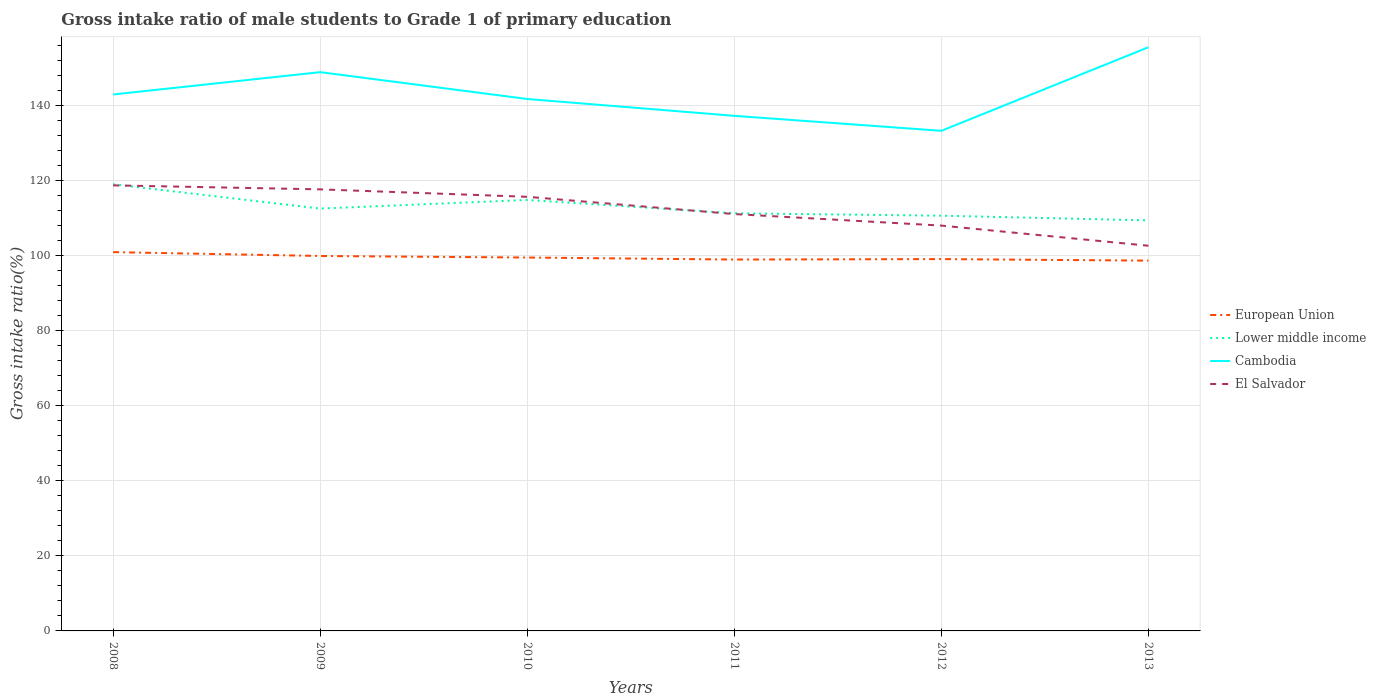How many different coloured lines are there?
Offer a very short reply. 4. Does the line corresponding to European Union intersect with the line corresponding to Lower middle income?
Your answer should be very brief. No. Across all years, what is the maximum gross intake ratio in Lower middle income?
Provide a short and direct response. 109.4. In which year was the gross intake ratio in Cambodia maximum?
Your answer should be very brief. 2012. What is the total gross intake ratio in El Salvador in the graph?
Your answer should be very brief. 1.98. What is the difference between the highest and the second highest gross intake ratio in European Union?
Your answer should be very brief. 2.26. What is the difference between the highest and the lowest gross intake ratio in European Union?
Your response must be concise. 2. Is the gross intake ratio in European Union strictly greater than the gross intake ratio in El Salvador over the years?
Provide a short and direct response. Yes. Are the values on the major ticks of Y-axis written in scientific E-notation?
Your response must be concise. No. Does the graph contain any zero values?
Your response must be concise. No. How many legend labels are there?
Provide a succinct answer. 4. How are the legend labels stacked?
Offer a terse response. Vertical. What is the title of the graph?
Offer a terse response. Gross intake ratio of male students to Grade 1 of primary education. What is the label or title of the X-axis?
Your answer should be very brief. Years. What is the label or title of the Y-axis?
Give a very brief answer. Gross intake ratio(%). What is the Gross intake ratio(%) of European Union in 2008?
Provide a short and direct response. 100.94. What is the Gross intake ratio(%) of Lower middle income in 2008?
Provide a succinct answer. 119.01. What is the Gross intake ratio(%) in Cambodia in 2008?
Offer a terse response. 142.95. What is the Gross intake ratio(%) in El Salvador in 2008?
Your response must be concise. 118.73. What is the Gross intake ratio(%) in European Union in 2009?
Make the answer very short. 99.91. What is the Gross intake ratio(%) in Lower middle income in 2009?
Provide a short and direct response. 112.54. What is the Gross intake ratio(%) of Cambodia in 2009?
Provide a short and direct response. 148.9. What is the Gross intake ratio(%) of El Salvador in 2009?
Make the answer very short. 117.67. What is the Gross intake ratio(%) of European Union in 2010?
Your answer should be very brief. 99.5. What is the Gross intake ratio(%) of Lower middle income in 2010?
Provide a short and direct response. 114.85. What is the Gross intake ratio(%) of Cambodia in 2010?
Ensure brevity in your answer.  141.75. What is the Gross intake ratio(%) in El Salvador in 2010?
Your response must be concise. 115.68. What is the Gross intake ratio(%) of European Union in 2011?
Offer a terse response. 98.96. What is the Gross intake ratio(%) of Lower middle income in 2011?
Make the answer very short. 111.29. What is the Gross intake ratio(%) of Cambodia in 2011?
Keep it short and to the point. 137.26. What is the Gross intake ratio(%) of El Salvador in 2011?
Your response must be concise. 111.08. What is the Gross intake ratio(%) of European Union in 2012?
Provide a short and direct response. 99.08. What is the Gross intake ratio(%) of Lower middle income in 2012?
Offer a very short reply. 110.65. What is the Gross intake ratio(%) in Cambodia in 2012?
Provide a short and direct response. 133.27. What is the Gross intake ratio(%) in El Salvador in 2012?
Give a very brief answer. 108.01. What is the Gross intake ratio(%) of European Union in 2013?
Offer a very short reply. 98.68. What is the Gross intake ratio(%) in Lower middle income in 2013?
Ensure brevity in your answer.  109.4. What is the Gross intake ratio(%) of Cambodia in 2013?
Provide a short and direct response. 155.54. What is the Gross intake ratio(%) in El Salvador in 2013?
Offer a terse response. 102.64. Across all years, what is the maximum Gross intake ratio(%) of European Union?
Offer a terse response. 100.94. Across all years, what is the maximum Gross intake ratio(%) in Lower middle income?
Your answer should be very brief. 119.01. Across all years, what is the maximum Gross intake ratio(%) in Cambodia?
Your response must be concise. 155.54. Across all years, what is the maximum Gross intake ratio(%) in El Salvador?
Keep it short and to the point. 118.73. Across all years, what is the minimum Gross intake ratio(%) of European Union?
Your response must be concise. 98.68. Across all years, what is the minimum Gross intake ratio(%) of Lower middle income?
Your answer should be very brief. 109.4. Across all years, what is the minimum Gross intake ratio(%) of Cambodia?
Keep it short and to the point. 133.27. Across all years, what is the minimum Gross intake ratio(%) in El Salvador?
Your response must be concise. 102.64. What is the total Gross intake ratio(%) in European Union in the graph?
Your response must be concise. 597.07. What is the total Gross intake ratio(%) in Lower middle income in the graph?
Ensure brevity in your answer.  677.73. What is the total Gross intake ratio(%) in Cambodia in the graph?
Ensure brevity in your answer.  859.65. What is the total Gross intake ratio(%) in El Salvador in the graph?
Give a very brief answer. 673.82. What is the difference between the Gross intake ratio(%) in European Union in 2008 and that in 2009?
Give a very brief answer. 1.03. What is the difference between the Gross intake ratio(%) of Lower middle income in 2008 and that in 2009?
Offer a terse response. 6.47. What is the difference between the Gross intake ratio(%) of Cambodia in 2008 and that in 2009?
Give a very brief answer. -5.95. What is the difference between the Gross intake ratio(%) in El Salvador in 2008 and that in 2009?
Your answer should be very brief. 1.06. What is the difference between the Gross intake ratio(%) of European Union in 2008 and that in 2010?
Provide a succinct answer. 1.44. What is the difference between the Gross intake ratio(%) in Lower middle income in 2008 and that in 2010?
Offer a very short reply. 4.17. What is the difference between the Gross intake ratio(%) of Cambodia in 2008 and that in 2010?
Ensure brevity in your answer.  1.2. What is the difference between the Gross intake ratio(%) of El Salvador in 2008 and that in 2010?
Provide a succinct answer. 3.05. What is the difference between the Gross intake ratio(%) in European Union in 2008 and that in 2011?
Ensure brevity in your answer.  1.98. What is the difference between the Gross intake ratio(%) of Lower middle income in 2008 and that in 2011?
Provide a short and direct response. 7.72. What is the difference between the Gross intake ratio(%) in Cambodia in 2008 and that in 2011?
Make the answer very short. 5.69. What is the difference between the Gross intake ratio(%) of El Salvador in 2008 and that in 2011?
Give a very brief answer. 7.65. What is the difference between the Gross intake ratio(%) of European Union in 2008 and that in 2012?
Provide a succinct answer. 1.86. What is the difference between the Gross intake ratio(%) of Lower middle income in 2008 and that in 2012?
Your response must be concise. 8.36. What is the difference between the Gross intake ratio(%) in Cambodia in 2008 and that in 2012?
Provide a succinct answer. 9.68. What is the difference between the Gross intake ratio(%) in El Salvador in 2008 and that in 2012?
Your answer should be compact. 10.72. What is the difference between the Gross intake ratio(%) in European Union in 2008 and that in 2013?
Your answer should be very brief. 2.26. What is the difference between the Gross intake ratio(%) in Lower middle income in 2008 and that in 2013?
Offer a terse response. 9.62. What is the difference between the Gross intake ratio(%) of Cambodia in 2008 and that in 2013?
Offer a very short reply. -12.59. What is the difference between the Gross intake ratio(%) of El Salvador in 2008 and that in 2013?
Make the answer very short. 16.09. What is the difference between the Gross intake ratio(%) of European Union in 2009 and that in 2010?
Your response must be concise. 0.41. What is the difference between the Gross intake ratio(%) in Lower middle income in 2009 and that in 2010?
Make the answer very short. -2.3. What is the difference between the Gross intake ratio(%) of Cambodia in 2009 and that in 2010?
Keep it short and to the point. 7.15. What is the difference between the Gross intake ratio(%) in El Salvador in 2009 and that in 2010?
Offer a very short reply. 1.98. What is the difference between the Gross intake ratio(%) in European Union in 2009 and that in 2011?
Ensure brevity in your answer.  0.95. What is the difference between the Gross intake ratio(%) of Lower middle income in 2009 and that in 2011?
Keep it short and to the point. 1.26. What is the difference between the Gross intake ratio(%) in Cambodia in 2009 and that in 2011?
Your answer should be compact. 11.64. What is the difference between the Gross intake ratio(%) of El Salvador in 2009 and that in 2011?
Provide a succinct answer. 6.58. What is the difference between the Gross intake ratio(%) of European Union in 2009 and that in 2012?
Your answer should be compact. 0.83. What is the difference between the Gross intake ratio(%) of Lower middle income in 2009 and that in 2012?
Make the answer very short. 1.89. What is the difference between the Gross intake ratio(%) of Cambodia in 2009 and that in 2012?
Provide a short and direct response. 15.63. What is the difference between the Gross intake ratio(%) in El Salvador in 2009 and that in 2012?
Provide a succinct answer. 9.65. What is the difference between the Gross intake ratio(%) of European Union in 2009 and that in 2013?
Give a very brief answer. 1.24. What is the difference between the Gross intake ratio(%) in Lower middle income in 2009 and that in 2013?
Your answer should be compact. 3.15. What is the difference between the Gross intake ratio(%) of Cambodia in 2009 and that in 2013?
Offer a terse response. -6.64. What is the difference between the Gross intake ratio(%) in El Salvador in 2009 and that in 2013?
Ensure brevity in your answer.  15.02. What is the difference between the Gross intake ratio(%) of European Union in 2010 and that in 2011?
Provide a succinct answer. 0.54. What is the difference between the Gross intake ratio(%) in Lower middle income in 2010 and that in 2011?
Keep it short and to the point. 3.56. What is the difference between the Gross intake ratio(%) in Cambodia in 2010 and that in 2011?
Ensure brevity in your answer.  4.49. What is the difference between the Gross intake ratio(%) in El Salvador in 2010 and that in 2011?
Offer a very short reply. 4.6. What is the difference between the Gross intake ratio(%) in European Union in 2010 and that in 2012?
Offer a very short reply. 0.42. What is the difference between the Gross intake ratio(%) of Lower middle income in 2010 and that in 2012?
Your response must be concise. 4.19. What is the difference between the Gross intake ratio(%) of Cambodia in 2010 and that in 2012?
Offer a very short reply. 8.48. What is the difference between the Gross intake ratio(%) in El Salvador in 2010 and that in 2012?
Your response must be concise. 7.67. What is the difference between the Gross intake ratio(%) in European Union in 2010 and that in 2013?
Your answer should be very brief. 0.83. What is the difference between the Gross intake ratio(%) in Lower middle income in 2010 and that in 2013?
Keep it short and to the point. 5.45. What is the difference between the Gross intake ratio(%) of Cambodia in 2010 and that in 2013?
Ensure brevity in your answer.  -13.79. What is the difference between the Gross intake ratio(%) of El Salvador in 2010 and that in 2013?
Keep it short and to the point. 13.04. What is the difference between the Gross intake ratio(%) of European Union in 2011 and that in 2012?
Offer a terse response. -0.12. What is the difference between the Gross intake ratio(%) of Lower middle income in 2011 and that in 2012?
Ensure brevity in your answer.  0.64. What is the difference between the Gross intake ratio(%) of Cambodia in 2011 and that in 2012?
Your answer should be very brief. 3.99. What is the difference between the Gross intake ratio(%) of El Salvador in 2011 and that in 2012?
Offer a very short reply. 3.07. What is the difference between the Gross intake ratio(%) in European Union in 2011 and that in 2013?
Provide a succinct answer. 0.28. What is the difference between the Gross intake ratio(%) in Lower middle income in 2011 and that in 2013?
Provide a succinct answer. 1.89. What is the difference between the Gross intake ratio(%) in Cambodia in 2011 and that in 2013?
Provide a short and direct response. -18.28. What is the difference between the Gross intake ratio(%) in El Salvador in 2011 and that in 2013?
Provide a succinct answer. 8.44. What is the difference between the Gross intake ratio(%) in European Union in 2012 and that in 2013?
Offer a terse response. 0.41. What is the difference between the Gross intake ratio(%) of Lower middle income in 2012 and that in 2013?
Your answer should be compact. 1.26. What is the difference between the Gross intake ratio(%) in Cambodia in 2012 and that in 2013?
Your answer should be very brief. -22.27. What is the difference between the Gross intake ratio(%) of El Salvador in 2012 and that in 2013?
Offer a very short reply. 5.37. What is the difference between the Gross intake ratio(%) in European Union in 2008 and the Gross intake ratio(%) in Lower middle income in 2009?
Give a very brief answer. -11.6. What is the difference between the Gross intake ratio(%) of European Union in 2008 and the Gross intake ratio(%) of Cambodia in 2009?
Provide a short and direct response. -47.96. What is the difference between the Gross intake ratio(%) of European Union in 2008 and the Gross intake ratio(%) of El Salvador in 2009?
Offer a terse response. -16.73. What is the difference between the Gross intake ratio(%) in Lower middle income in 2008 and the Gross intake ratio(%) in Cambodia in 2009?
Your response must be concise. -29.89. What is the difference between the Gross intake ratio(%) of Lower middle income in 2008 and the Gross intake ratio(%) of El Salvador in 2009?
Provide a short and direct response. 1.35. What is the difference between the Gross intake ratio(%) of Cambodia in 2008 and the Gross intake ratio(%) of El Salvador in 2009?
Your response must be concise. 25.28. What is the difference between the Gross intake ratio(%) in European Union in 2008 and the Gross intake ratio(%) in Lower middle income in 2010?
Offer a terse response. -13.91. What is the difference between the Gross intake ratio(%) of European Union in 2008 and the Gross intake ratio(%) of Cambodia in 2010?
Your response must be concise. -40.81. What is the difference between the Gross intake ratio(%) of European Union in 2008 and the Gross intake ratio(%) of El Salvador in 2010?
Your answer should be very brief. -14.74. What is the difference between the Gross intake ratio(%) in Lower middle income in 2008 and the Gross intake ratio(%) in Cambodia in 2010?
Give a very brief answer. -22.73. What is the difference between the Gross intake ratio(%) of Lower middle income in 2008 and the Gross intake ratio(%) of El Salvador in 2010?
Offer a terse response. 3.33. What is the difference between the Gross intake ratio(%) in Cambodia in 2008 and the Gross intake ratio(%) in El Salvador in 2010?
Your answer should be compact. 27.27. What is the difference between the Gross intake ratio(%) of European Union in 2008 and the Gross intake ratio(%) of Lower middle income in 2011?
Provide a short and direct response. -10.35. What is the difference between the Gross intake ratio(%) in European Union in 2008 and the Gross intake ratio(%) in Cambodia in 2011?
Ensure brevity in your answer.  -36.32. What is the difference between the Gross intake ratio(%) in European Union in 2008 and the Gross intake ratio(%) in El Salvador in 2011?
Offer a very short reply. -10.14. What is the difference between the Gross intake ratio(%) in Lower middle income in 2008 and the Gross intake ratio(%) in Cambodia in 2011?
Offer a very short reply. -18.25. What is the difference between the Gross intake ratio(%) in Lower middle income in 2008 and the Gross intake ratio(%) in El Salvador in 2011?
Keep it short and to the point. 7.93. What is the difference between the Gross intake ratio(%) of Cambodia in 2008 and the Gross intake ratio(%) of El Salvador in 2011?
Provide a succinct answer. 31.87. What is the difference between the Gross intake ratio(%) of European Union in 2008 and the Gross intake ratio(%) of Lower middle income in 2012?
Offer a very short reply. -9.71. What is the difference between the Gross intake ratio(%) in European Union in 2008 and the Gross intake ratio(%) in Cambodia in 2012?
Make the answer very short. -32.33. What is the difference between the Gross intake ratio(%) in European Union in 2008 and the Gross intake ratio(%) in El Salvador in 2012?
Your response must be concise. -7.07. What is the difference between the Gross intake ratio(%) in Lower middle income in 2008 and the Gross intake ratio(%) in Cambodia in 2012?
Provide a succinct answer. -14.25. What is the difference between the Gross intake ratio(%) of Lower middle income in 2008 and the Gross intake ratio(%) of El Salvador in 2012?
Ensure brevity in your answer.  11. What is the difference between the Gross intake ratio(%) of Cambodia in 2008 and the Gross intake ratio(%) of El Salvador in 2012?
Your response must be concise. 34.94. What is the difference between the Gross intake ratio(%) in European Union in 2008 and the Gross intake ratio(%) in Lower middle income in 2013?
Keep it short and to the point. -8.46. What is the difference between the Gross intake ratio(%) of European Union in 2008 and the Gross intake ratio(%) of Cambodia in 2013?
Keep it short and to the point. -54.6. What is the difference between the Gross intake ratio(%) of European Union in 2008 and the Gross intake ratio(%) of El Salvador in 2013?
Keep it short and to the point. -1.7. What is the difference between the Gross intake ratio(%) in Lower middle income in 2008 and the Gross intake ratio(%) in Cambodia in 2013?
Provide a short and direct response. -36.52. What is the difference between the Gross intake ratio(%) in Lower middle income in 2008 and the Gross intake ratio(%) in El Salvador in 2013?
Ensure brevity in your answer.  16.37. What is the difference between the Gross intake ratio(%) in Cambodia in 2008 and the Gross intake ratio(%) in El Salvador in 2013?
Give a very brief answer. 40.31. What is the difference between the Gross intake ratio(%) in European Union in 2009 and the Gross intake ratio(%) in Lower middle income in 2010?
Provide a succinct answer. -14.94. What is the difference between the Gross intake ratio(%) of European Union in 2009 and the Gross intake ratio(%) of Cambodia in 2010?
Your answer should be very brief. -41.83. What is the difference between the Gross intake ratio(%) in European Union in 2009 and the Gross intake ratio(%) in El Salvador in 2010?
Offer a terse response. -15.77. What is the difference between the Gross intake ratio(%) in Lower middle income in 2009 and the Gross intake ratio(%) in Cambodia in 2010?
Make the answer very short. -29.2. What is the difference between the Gross intake ratio(%) of Lower middle income in 2009 and the Gross intake ratio(%) of El Salvador in 2010?
Offer a terse response. -3.14. What is the difference between the Gross intake ratio(%) of Cambodia in 2009 and the Gross intake ratio(%) of El Salvador in 2010?
Make the answer very short. 33.22. What is the difference between the Gross intake ratio(%) in European Union in 2009 and the Gross intake ratio(%) in Lower middle income in 2011?
Offer a very short reply. -11.38. What is the difference between the Gross intake ratio(%) in European Union in 2009 and the Gross intake ratio(%) in Cambodia in 2011?
Ensure brevity in your answer.  -37.35. What is the difference between the Gross intake ratio(%) in European Union in 2009 and the Gross intake ratio(%) in El Salvador in 2011?
Your answer should be compact. -11.17. What is the difference between the Gross intake ratio(%) of Lower middle income in 2009 and the Gross intake ratio(%) of Cambodia in 2011?
Keep it short and to the point. -24.72. What is the difference between the Gross intake ratio(%) of Lower middle income in 2009 and the Gross intake ratio(%) of El Salvador in 2011?
Your response must be concise. 1.46. What is the difference between the Gross intake ratio(%) in Cambodia in 2009 and the Gross intake ratio(%) in El Salvador in 2011?
Give a very brief answer. 37.81. What is the difference between the Gross intake ratio(%) in European Union in 2009 and the Gross intake ratio(%) in Lower middle income in 2012?
Your answer should be very brief. -10.74. What is the difference between the Gross intake ratio(%) in European Union in 2009 and the Gross intake ratio(%) in Cambodia in 2012?
Provide a short and direct response. -33.35. What is the difference between the Gross intake ratio(%) of European Union in 2009 and the Gross intake ratio(%) of El Salvador in 2012?
Your answer should be very brief. -8.1. What is the difference between the Gross intake ratio(%) in Lower middle income in 2009 and the Gross intake ratio(%) in Cambodia in 2012?
Provide a succinct answer. -20.72. What is the difference between the Gross intake ratio(%) of Lower middle income in 2009 and the Gross intake ratio(%) of El Salvador in 2012?
Your answer should be very brief. 4.53. What is the difference between the Gross intake ratio(%) of Cambodia in 2009 and the Gross intake ratio(%) of El Salvador in 2012?
Provide a short and direct response. 40.89. What is the difference between the Gross intake ratio(%) in European Union in 2009 and the Gross intake ratio(%) in Lower middle income in 2013?
Your response must be concise. -9.49. What is the difference between the Gross intake ratio(%) of European Union in 2009 and the Gross intake ratio(%) of Cambodia in 2013?
Ensure brevity in your answer.  -55.62. What is the difference between the Gross intake ratio(%) in European Union in 2009 and the Gross intake ratio(%) in El Salvador in 2013?
Your answer should be very brief. -2.73. What is the difference between the Gross intake ratio(%) of Lower middle income in 2009 and the Gross intake ratio(%) of Cambodia in 2013?
Your answer should be compact. -42.99. What is the difference between the Gross intake ratio(%) in Lower middle income in 2009 and the Gross intake ratio(%) in El Salvador in 2013?
Your answer should be compact. 9.9. What is the difference between the Gross intake ratio(%) of Cambodia in 2009 and the Gross intake ratio(%) of El Salvador in 2013?
Offer a terse response. 46.25. What is the difference between the Gross intake ratio(%) of European Union in 2010 and the Gross intake ratio(%) of Lower middle income in 2011?
Keep it short and to the point. -11.79. What is the difference between the Gross intake ratio(%) in European Union in 2010 and the Gross intake ratio(%) in Cambodia in 2011?
Provide a short and direct response. -37.76. What is the difference between the Gross intake ratio(%) of European Union in 2010 and the Gross intake ratio(%) of El Salvador in 2011?
Your answer should be very brief. -11.58. What is the difference between the Gross intake ratio(%) in Lower middle income in 2010 and the Gross intake ratio(%) in Cambodia in 2011?
Give a very brief answer. -22.41. What is the difference between the Gross intake ratio(%) of Lower middle income in 2010 and the Gross intake ratio(%) of El Salvador in 2011?
Ensure brevity in your answer.  3.76. What is the difference between the Gross intake ratio(%) in Cambodia in 2010 and the Gross intake ratio(%) in El Salvador in 2011?
Ensure brevity in your answer.  30.66. What is the difference between the Gross intake ratio(%) of European Union in 2010 and the Gross intake ratio(%) of Lower middle income in 2012?
Make the answer very short. -11.15. What is the difference between the Gross intake ratio(%) in European Union in 2010 and the Gross intake ratio(%) in Cambodia in 2012?
Your answer should be compact. -33.76. What is the difference between the Gross intake ratio(%) of European Union in 2010 and the Gross intake ratio(%) of El Salvador in 2012?
Provide a short and direct response. -8.51. What is the difference between the Gross intake ratio(%) of Lower middle income in 2010 and the Gross intake ratio(%) of Cambodia in 2012?
Provide a succinct answer. -18.42. What is the difference between the Gross intake ratio(%) of Lower middle income in 2010 and the Gross intake ratio(%) of El Salvador in 2012?
Offer a very short reply. 6.83. What is the difference between the Gross intake ratio(%) in Cambodia in 2010 and the Gross intake ratio(%) in El Salvador in 2012?
Offer a very short reply. 33.73. What is the difference between the Gross intake ratio(%) in European Union in 2010 and the Gross intake ratio(%) in Lower middle income in 2013?
Your answer should be compact. -9.89. What is the difference between the Gross intake ratio(%) of European Union in 2010 and the Gross intake ratio(%) of Cambodia in 2013?
Offer a terse response. -56.03. What is the difference between the Gross intake ratio(%) in European Union in 2010 and the Gross intake ratio(%) in El Salvador in 2013?
Provide a short and direct response. -3.14. What is the difference between the Gross intake ratio(%) in Lower middle income in 2010 and the Gross intake ratio(%) in Cambodia in 2013?
Your answer should be very brief. -40.69. What is the difference between the Gross intake ratio(%) of Lower middle income in 2010 and the Gross intake ratio(%) of El Salvador in 2013?
Keep it short and to the point. 12.2. What is the difference between the Gross intake ratio(%) in Cambodia in 2010 and the Gross intake ratio(%) in El Salvador in 2013?
Your answer should be very brief. 39.1. What is the difference between the Gross intake ratio(%) in European Union in 2011 and the Gross intake ratio(%) in Lower middle income in 2012?
Offer a terse response. -11.69. What is the difference between the Gross intake ratio(%) of European Union in 2011 and the Gross intake ratio(%) of Cambodia in 2012?
Your response must be concise. -34.3. What is the difference between the Gross intake ratio(%) in European Union in 2011 and the Gross intake ratio(%) in El Salvador in 2012?
Ensure brevity in your answer.  -9.05. What is the difference between the Gross intake ratio(%) in Lower middle income in 2011 and the Gross intake ratio(%) in Cambodia in 2012?
Offer a terse response. -21.98. What is the difference between the Gross intake ratio(%) of Lower middle income in 2011 and the Gross intake ratio(%) of El Salvador in 2012?
Give a very brief answer. 3.28. What is the difference between the Gross intake ratio(%) of Cambodia in 2011 and the Gross intake ratio(%) of El Salvador in 2012?
Offer a very short reply. 29.25. What is the difference between the Gross intake ratio(%) in European Union in 2011 and the Gross intake ratio(%) in Lower middle income in 2013?
Provide a short and direct response. -10.44. What is the difference between the Gross intake ratio(%) of European Union in 2011 and the Gross intake ratio(%) of Cambodia in 2013?
Your answer should be compact. -56.58. What is the difference between the Gross intake ratio(%) in European Union in 2011 and the Gross intake ratio(%) in El Salvador in 2013?
Offer a very short reply. -3.68. What is the difference between the Gross intake ratio(%) in Lower middle income in 2011 and the Gross intake ratio(%) in Cambodia in 2013?
Ensure brevity in your answer.  -44.25. What is the difference between the Gross intake ratio(%) of Lower middle income in 2011 and the Gross intake ratio(%) of El Salvador in 2013?
Your answer should be compact. 8.64. What is the difference between the Gross intake ratio(%) in Cambodia in 2011 and the Gross intake ratio(%) in El Salvador in 2013?
Provide a short and direct response. 34.62. What is the difference between the Gross intake ratio(%) of European Union in 2012 and the Gross intake ratio(%) of Lower middle income in 2013?
Keep it short and to the point. -10.31. What is the difference between the Gross intake ratio(%) of European Union in 2012 and the Gross intake ratio(%) of Cambodia in 2013?
Offer a very short reply. -56.45. What is the difference between the Gross intake ratio(%) in European Union in 2012 and the Gross intake ratio(%) in El Salvador in 2013?
Make the answer very short. -3.56. What is the difference between the Gross intake ratio(%) in Lower middle income in 2012 and the Gross intake ratio(%) in Cambodia in 2013?
Ensure brevity in your answer.  -44.88. What is the difference between the Gross intake ratio(%) of Lower middle income in 2012 and the Gross intake ratio(%) of El Salvador in 2013?
Your answer should be compact. 8.01. What is the difference between the Gross intake ratio(%) in Cambodia in 2012 and the Gross intake ratio(%) in El Salvador in 2013?
Keep it short and to the point. 30.62. What is the average Gross intake ratio(%) of European Union per year?
Provide a short and direct response. 99.51. What is the average Gross intake ratio(%) of Lower middle income per year?
Your response must be concise. 112.96. What is the average Gross intake ratio(%) in Cambodia per year?
Give a very brief answer. 143.28. What is the average Gross intake ratio(%) of El Salvador per year?
Give a very brief answer. 112.3. In the year 2008, what is the difference between the Gross intake ratio(%) in European Union and Gross intake ratio(%) in Lower middle income?
Make the answer very short. -18.07. In the year 2008, what is the difference between the Gross intake ratio(%) in European Union and Gross intake ratio(%) in Cambodia?
Offer a very short reply. -42.01. In the year 2008, what is the difference between the Gross intake ratio(%) in European Union and Gross intake ratio(%) in El Salvador?
Your response must be concise. -17.79. In the year 2008, what is the difference between the Gross intake ratio(%) of Lower middle income and Gross intake ratio(%) of Cambodia?
Give a very brief answer. -23.94. In the year 2008, what is the difference between the Gross intake ratio(%) in Lower middle income and Gross intake ratio(%) in El Salvador?
Offer a terse response. 0.28. In the year 2008, what is the difference between the Gross intake ratio(%) of Cambodia and Gross intake ratio(%) of El Salvador?
Your answer should be very brief. 24.22. In the year 2009, what is the difference between the Gross intake ratio(%) of European Union and Gross intake ratio(%) of Lower middle income?
Provide a short and direct response. -12.63. In the year 2009, what is the difference between the Gross intake ratio(%) in European Union and Gross intake ratio(%) in Cambodia?
Provide a succinct answer. -48.99. In the year 2009, what is the difference between the Gross intake ratio(%) in European Union and Gross intake ratio(%) in El Salvador?
Your response must be concise. -17.76. In the year 2009, what is the difference between the Gross intake ratio(%) of Lower middle income and Gross intake ratio(%) of Cambodia?
Your response must be concise. -36.35. In the year 2009, what is the difference between the Gross intake ratio(%) in Lower middle income and Gross intake ratio(%) in El Salvador?
Make the answer very short. -5.12. In the year 2009, what is the difference between the Gross intake ratio(%) in Cambodia and Gross intake ratio(%) in El Salvador?
Make the answer very short. 31.23. In the year 2010, what is the difference between the Gross intake ratio(%) of European Union and Gross intake ratio(%) of Lower middle income?
Provide a succinct answer. -15.34. In the year 2010, what is the difference between the Gross intake ratio(%) of European Union and Gross intake ratio(%) of Cambodia?
Your answer should be compact. -42.24. In the year 2010, what is the difference between the Gross intake ratio(%) in European Union and Gross intake ratio(%) in El Salvador?
Your answer should be compact. -16.18. In the year 2010, what is the difference between the Gross intake ratio(%) of Lower middle income and Gross intake ratio(%) of Cambodia?
Your answer should be compact. -26.9. In the year 2010, what is the difference between the Gross intake ratio(%) in Lower middle income and Gross intake ratio(%) in El Salvador?
Ensure brevity in your answer.  -0.84. In the year 2010, what is the difference between the Gross intake ratio(%) of Cambodia and Gross intake ratio(%) of El Salvador?
Keep it short and to the point. 26.06. In the year 2011, what is the difference between the Gross intake ratio(%) in European Union and Gross intake ratio(%) in Lower middle income?
Provide a short and direct response. -12.33. In the year 2011, what is the difference between the Gross intake ratio(%) of European Union and Gross intake ratio(%) of Cambodia?
Give a very brief answer. -38.3. In the year 2011, what is the difference between the Gross intake ratio(%) of European Union and Gross intake ratio(%) of El Salvador?
Keep it short and to the point. -12.12. In the year 2011, what is the difference between the Gross intake ratio(%) in Lower middle income and Gross intake ratio(%) in Cambodia?
Give a very brief answer. -25.97. In the year 2011, what is the difference between the Gross intake ratio(%) in Lower middle income and Gross intake ratio(%) in El Salvador?
Make the answer very short. 0.2. In the year 2011, what is the difference between the Gross intake ratio(%) in Cambodia and Gross intake ratio(%) in El Salvador?
Give a very brief answer. 26.18. In the year 2012, what is the difference between the Gross intake ratio(%) in European Union and Gross intake ratio(%) in Lower middle income?
Your answer should be very brief. -11.57. In the year 2012, what is the difference between the Gross intake ratio(%) in European Union and Gross intake ratio(%) in Cambodia?
Provide a short and direct response. -34.18. In the year 2012, what is the difference between the Gross intake ratio(%) in European Union and Gross intake ratio(%) in El Salvador?
Give a very brief answer. -8.93. In the year 2012, what is the difference between the Gross intake ratio(%) of Lower middle income and Gross intake ratio(%) of Cambodia?
Give a very brief answer. -22.61. In the year 2012, what is the difference between the Gross intake ratio(%) in Lower middle income and Gross intake ratio(%) in El Salvador?
Ensure brevity in your answer.  2.64. In the year 2012, what is the difference between the Gross intake ratio(%) of Cambodia and Gross intake ratio(%) of El Salvador?
Your answer should be very brief. 25.25. In the year 2013, what is the difference between the Gross intake ratio(%) in European Union and Gross intake ratio(%) in Lower middle income?
Your answer should be compact. -10.72. In the year 2013, what is the difference between the Gross intake ratio(%) in European Union and Gross intake ratio(%) in Cambodia?
Provide a succinct answer. -56.86. In the year 2013, what is the difference between the Gross intake ratio(%) in European Union and Gross intake ratio(%) in El Salvador?
Offer a terse response. -3.97. In the year 2013, what is the difference between the Gross intake ratio(%) of Lower middle income and Gross intake ratio(%) of Cambodia?
Your response must be concise. -46.14. In the year 2013, what is the difference between the Gross intake ratio(%) of Lower middle income and Gross intake ratio(%) of El Salvador?
Give a very brief answer. 6.75. In the year 2013, what is the difference between the Gross intake ratio(%) in Cambodia and Gross intake ratio(%) in El Salvador?
Your response must be concise. 52.89. What is the ratio of the Gross intake ratio(%) in European Union in 2008 to that in 2009?
Provide a short and direct response. 1.01. What is the ratio of the Gross intake ratio(%) of Lower middle income in 2008 to that in 2009?
Offer a very short reply. 1.06. What is the ratio of the Gross intake ratio(%) in Cambodia in 2008 to that in 2009?
Your response must be concise. 0.96. What is the ratio of the Gross intake ratio(%) of El Salvador in 2008 to that in 2009?
Provide a succinct answer. 1.01. What is the ratio of the Gross intake ratio(%) in European Union in 2008 to that in 2010?
Offer a very short reply. 1.01. What is the ratio of the Gross intake ratio(%) in Lower middle income in 2008 to that in 2010?
Offer a terse response. 1.04. What is the ratio of the Gross intake ratio(%) in Cambodia in 2008 to that in 2010?
Your answer should be very brief. 1.01. What is the ratio of the Gross intake ratio(%) of El Salvador in 2008 to that in 2010?
Your answer should be very brief. 1.03. What is the ratio of the Gross intake ratio(%) in European Union in 2008 to that in 2011?
Your answer should be compact. 1.02. What is the ratio of the Gross intake ratio(%) in Lower middle income in 2008 to that in 2011?
Your response must be concise. 1.07. What is the ratio of the Gross intake ratio(%) of Cambodia in 2008 to that in 2011?
Your response must be concise. 1.04. What is the ratio of the Gross intake ratio(%) in El Salvador in 2008 to that in 2011?
Keep it short and to the point. 1.07. What is the ratio of the Gross intake ratio(%) in European Union in 2008 to that in 2012?
Your answer should be compact. 1.02. What is the ratio of the Gross intake ratio(%) of Lower middle income in 2008 to that in 2012?
Ensure brevity in your answer.  1.08. What is the ratio of the Gross intake ratio(%) in Cambodia in 2008 to that in 2012?
Offer a very short reply. 1.07. What is the ratio of the Gross intake ratio(%) of El Salvador in 2008 to that in 2012?
Give a very brief answer. 1.1. What is the ratio of the Gross intake ratio(%) in European Union in 2008 to that in 2013?
Your response must be concise. 1.02. What is the ratio of the Gross intake ratio(%) in Lower middle income in 2008 to that in 2013?
Offer a very short reply. 1.09. What is the ratio of the Gross intake ratio(%) in Cambodia in 2008 to that in 2013?
Your response must be concise. 0.92. What is the ratio of the Gross intake ratio(%) in El Salvador in 2008 to that in 2013?
Make the answer very short. 1.16. What is the ratio of the Gross intake ratio(%) of European Union in 2009 to that in 2010?
Your answer should be very brief. 1. What is the ratio of the Gross intake ratio(%) in Lower middle income in 2009 to that in 2010?
Your answer should be compact. 0.98. What is the ratio of the Gross intake ratio(%) of Cambodia in 2009 to that in 2010?
Keep it short and to the point. 1.05. What is the ratio of the Gross intake ratio(%) in El Salvador in 2009 to that in 2010?
Make the answer very short. 1.02. What is the ratio of the Gross intake ratio(%) in European Union in 2009 to that in 2011?
Keep it short and to the point. 1.01. What is the ratio of the Gross intake ratio(%) in Lower middle income in 2009 to that in 2011?
Keep it short and to the point. 1.01. What is the ratio of the Gross intake ratio(%) of Cambodia in 2009 to that in 2011?
Make the answer very short. 1.08. What is the ratio of the Gross intake ratio(%) of El Salvador in 2009 to that in 2011?
Ensure brevity in your answer.  1.06. What is the ratio of the Gross intake ratio(%) in European Union in 2009 to that in 2012?
Make the answer very short. 1.01. What is the ratio of the Gross intake ratio(%) of Lower middle income in 2009 to that in 2012?
Ensure brevity in your answer.  1.02. What is the ratio of the Gross intake ratio(%) of Cambodia in 2009 to that in 2012?
Keep it short and to the point. 1.12. What is the ratio of the Gross intake ratio(%) in El Salvador in 2009 to that in 2012?
Offer a very short reply. 1.09. What is the ratio of the Gross intake ratio(%) of European Union in 2009 to that in 2013?
Ensure brevity in your answer.  1.01. What is the ratio of the Gross intake ratio(%) of Lower middle income in 2009 to that in 2013?
Give a very brief answer. 1.03. What is the ratio of the Gross intake ratio(%) of Cambodia in 2009 to that in 2013?
Your answer should be very brief. 0.96. What is the ratio of the Gross intake ratio(%) of El Salvador in 2009 to that in 2013?
Your answer should be compact. 1.15. What is the ratio of the Gross intake ratio(%) in Lower middle income in 2010 to that in 2011?
Keep it short and to the point. 1.03. What is the ratio of the Gross intake ratio(%) of Cambodia in 2010 to that in 2011?
Keep it short and to the point. 1.03. What is the ratio of the Gross intake ratio(%) in El Salvador in 2010 to that in 2011?
Your answer should be compact. 1.04. What is the ratio of the Gross intake ratio(%) of European Union in 2010 to that in 2012?
Ensure brevity in your answer.  1. What is the ratio of the Gross intake ratio(%) in Lower middle income in 2010 to that in 2012?
Offer a terse response. 1.04. What is the ratio of the Gross intake ratio(%) in Cambodia in 2010 to that in 2012?
Your answer should be compact. 1.06. What is the ratio of the Gross intake ratio(%) in El Salvador in 2010 to that in 2012?
Your answer should be compact. 1.07. What is the ratio of the Gross intake ratio(%) in European Union in 2010 to that in 2013?
Provide a short and direct response. 1.01. What is the ratio of the Gross intake ratio(%) of Lower middle income in 2010 to that in 2013?
Ensure brevity in your answer.  1.05. What is the ratio of the Gross intake ratio(%) in Cambodia in 2010 to that in 2013?
Your answer should be compact. 0.91. What is the ratio of the Gross intake ratio(%) of El Salvador in 2010 to that in 2013?
Your answer should be compact. 1.13. What is the ratio of the Gross intake ratio(%) of Lower middle income in 2011 to that in 2012?
Offer a terse response. 1.01. What is the ratio of the Gross intake ratio(%) of El Salvador in 2011 to that in 2012?
Ensure brevity in your answer.  1.03. What is the ratio of the Gross intake ratio(%) of Lower middle income in 2011 to that in 2013?
Provide a succinct answer. 1.02. What is the ratio of the Gross intake ratio(%) of Cambodia in 2011 to that in 2013?
Offer a terse response. 0.88. What is the ratio of the Gross intake ratio(%) in El Salvador in 2011 to that in 2013?
Give a very brief answer. 1.08. What is the ratio of the Gross intake ratio(%) of Lower middle income in 2012 to that in 2013?
Provide a short and direct response. 1.01. What is the ratio of the Gross intake ratio(%) of Cambodia in 2012 to that in 2013?
Offer a very short reply. 0.86. What is the ratio of the Gross intake ratio(%) in El Salvador in 2012 to that in 2013?
Provide a succinct answer. 1.05. What is the difference between the highest and the second highest Gross intake ratio(%) in European Union?
Keep it short and to the point. 1.03. What is the difference between the highest and the second highest Gross intake ratio(%) of Lower middle income?
Provide a succinct answer. 4.17. What is the difference between the highest and the second highest Gross intake ratio(%) in Cambodia?
Make the answer very short. 6.64. What is the difference between the highest and the second highest Gross intake ratio(%) in El Salvador?
Provide a succinct answer. 1.06. What is the difference between the highest and the lowest Gross intake ratio(%) in European Union?
Your answer should be very brief. 2.26. What is the difference between the highest and the lowest Gross intake ratio(%) in Lower middle income?
Give a very brief answer. 9.62. What is the difference between the highest and the lowest Gross intake ratio(%) in Cambodia?
Keep it short and to the point. 22.27. What is the difference between the highest and the lowest Gross intake ratio(%) in El Salvador?
Keep it short and to the point. 16.09. 